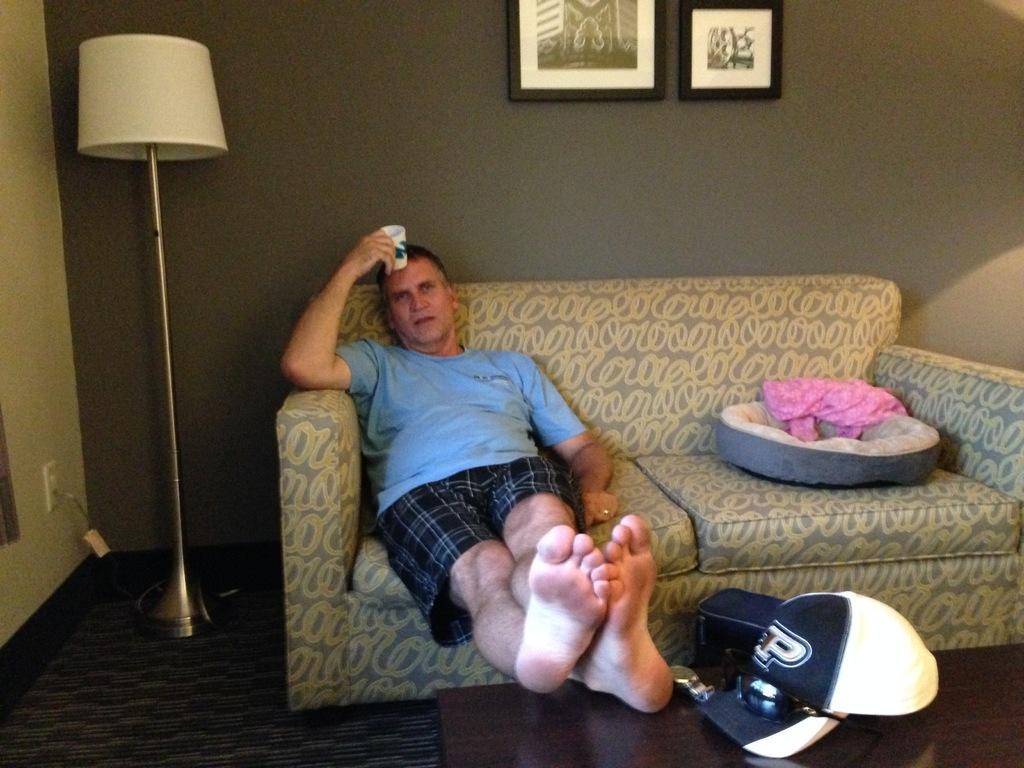Describe this image in one or two sentences. This picture is clicked inside the room. In the center we can see a person wearing t-shirt, holding some object and sitting on the couch and placing his legs on the top of the wooden table and we can see a cap, sunglasses and some other items. In the background we can see the lamp, picture frames hanging on the wall and the floor carpet and a wall socket. 